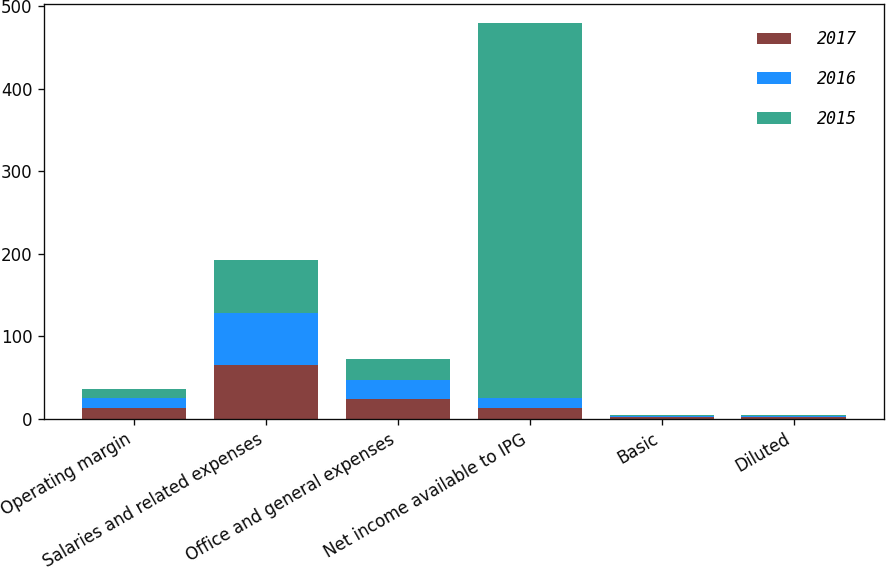Convert chart to OTSL. <chart><loc_0><loc_0><loc_500><loc_500><stacked_bar_chart><ecel><fcel>Operating margin<fcel>Salaries and related expenses<fcel>Office and general expenses<fcel>Net income available to IPG<fcel>Basic<fcel>Diluted<nl><fcel>2017<fcel>12.4<fcel>64.3<fcel>23.4<fcel>12.2<fcel>1.49<fcel>1.46<nl><fcel>2016<fcel>12<fcel>64.2<fcel>23.8<fcel>12.2<fcel>1.53<fcel>1.49<nl><fcel>2015<fcel>11.5<fcel>63.8<fcel>24.7<fcel>454.6<fcel>1.11<fcel>1.09<nl></chart> 